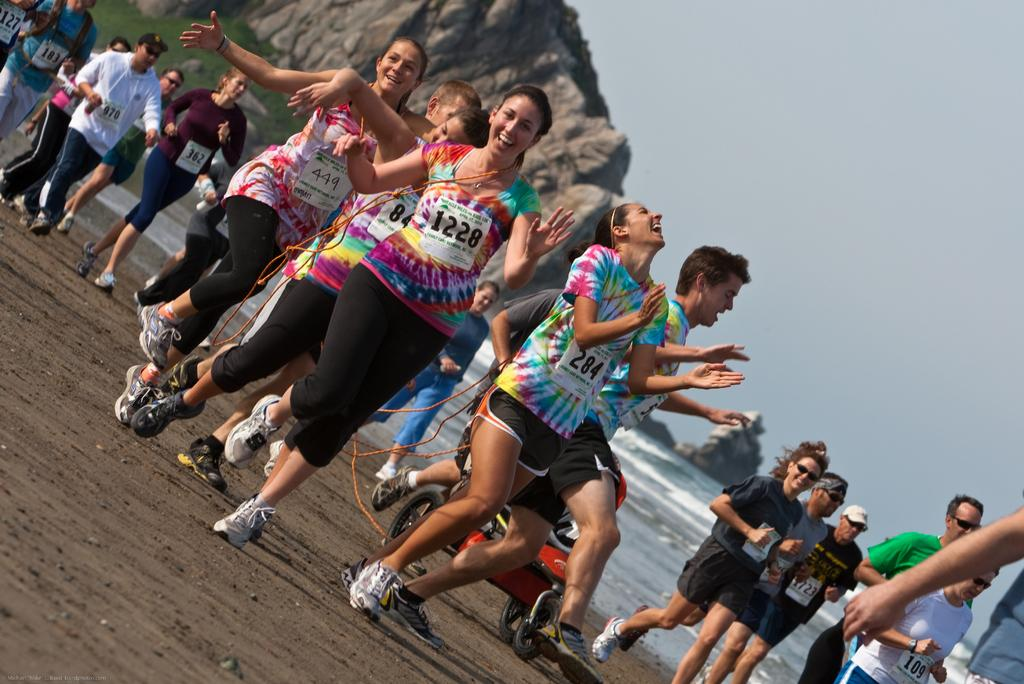What are the persons in the image doing? The persons in the image are running on the ground. What can be seen in the background of the image? In the background of the image, there is a hill, rocks, water, sky, and grass. Can you describe the terrain where the persons are running? The terrain appears to be grassy, as there is grass visible in the background. How many babies are flying with wings in the image? There are no babies or wings present in the image. 